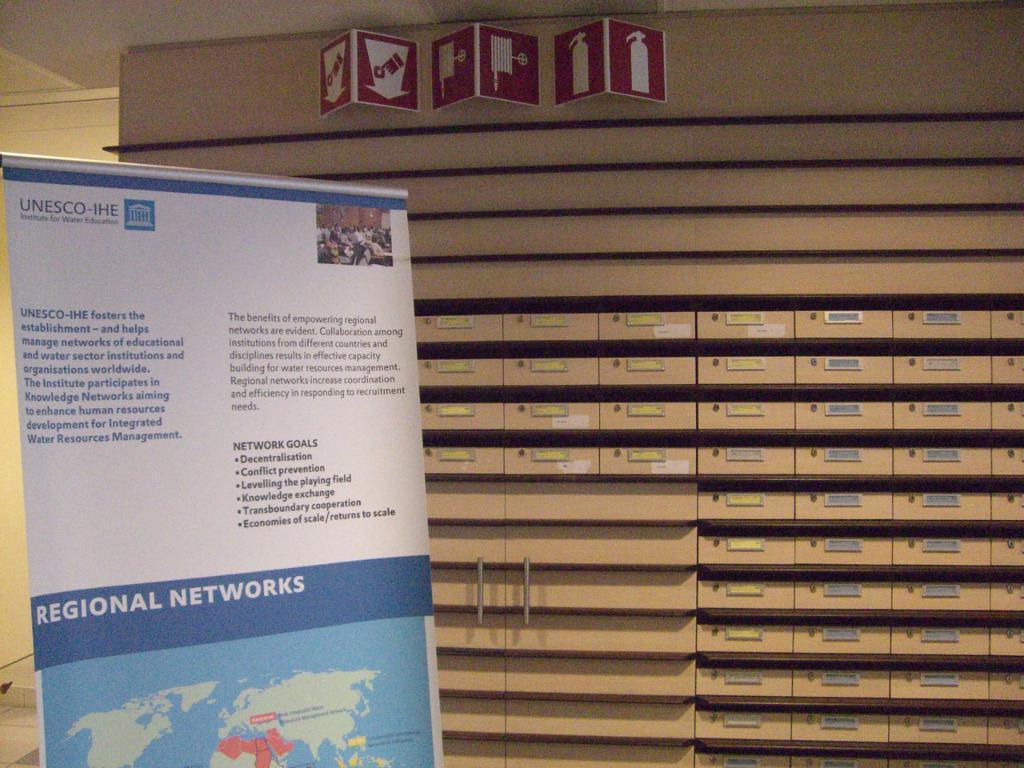Could you give a brief overview of what you see in this image? On the left corner of the picture, we see a white banner with some text written on it. Behind that, we see a cupboard which is brown in color. At the top of the picture, we see red color boards. In the background, we see a wall which is white in color. 